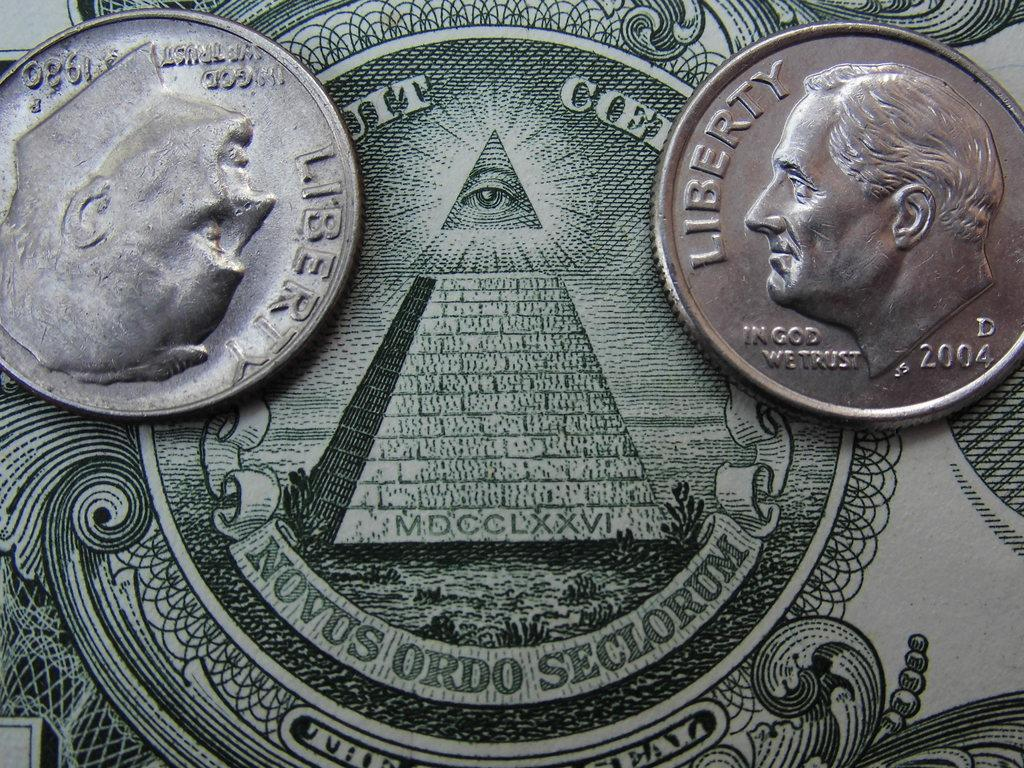Provide a one-sentence caption for the provided image. a dime that has the word liberty on it. 